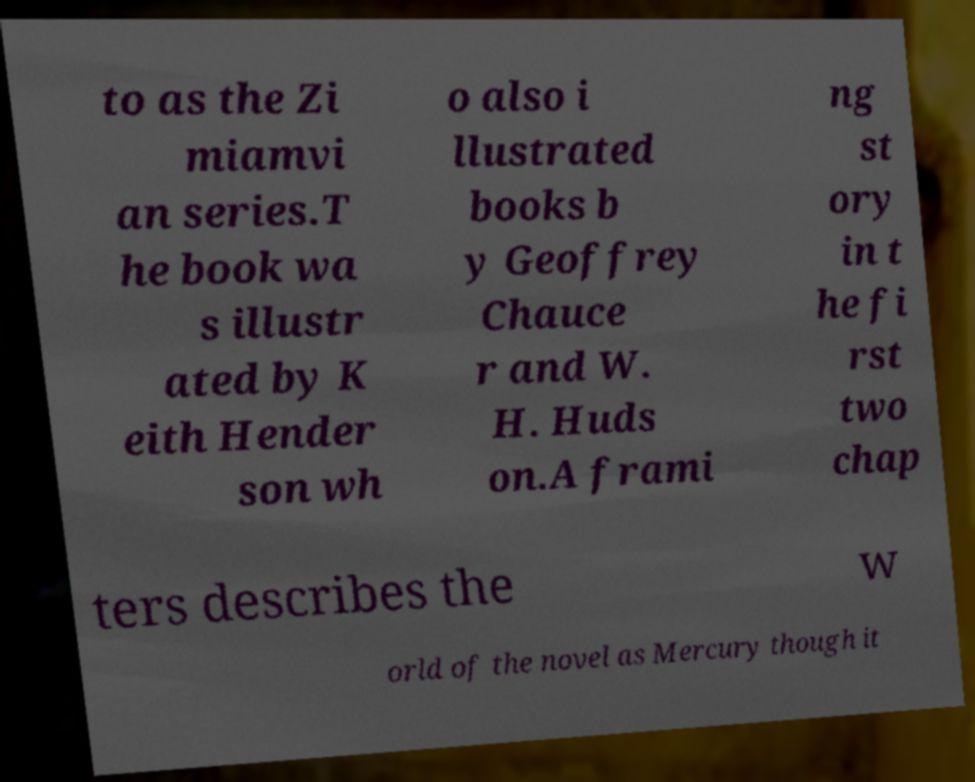What messages or text are displayed in this image? I need them in a readable, typed format. to as the Zi miamvi an series.T he book wa s illustr ated by K eith Hender son wh o also i llustrated books b y Geoffrey Chauce r and W. H. Huds on.A frami ng st ory in t he fi rst two chap ters describes the w orld of the novel as Mercury though it 